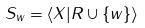<formula> <loc_0><loc_0><loc_500><loc_500>S _ { w } = \langle X | R \cup \{ w \} \rangle</formula> 